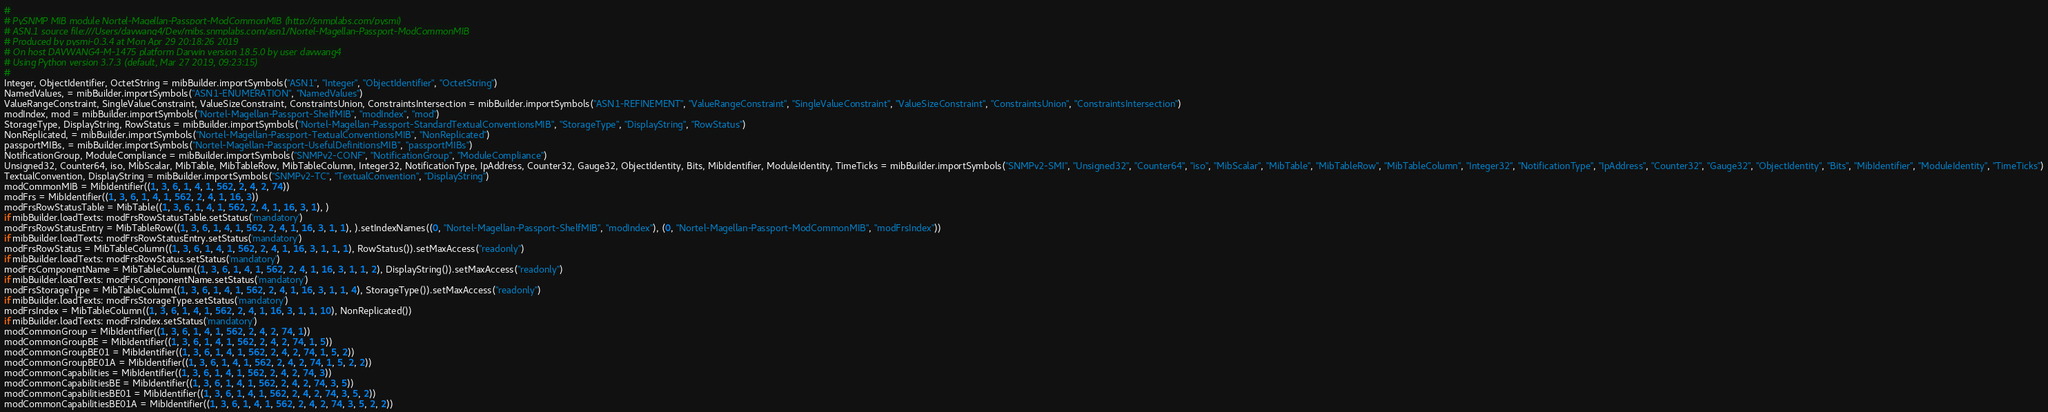<code> <loc_0><loc_0><loc_500><loc_500><_Python_>#
# PySNMP MIB module Nortel-Magellan-Passport-ModCommonMIB (http://snmplabs.com/pysmi)
# ASN.1 source file:///Users/davwang4/Dev/mibs.snmplabs.com/asn1/Nortel-Magellan-Passport-ModCommonMIB
# Produced by pysmi-0.3.4 at Mon Apr 29 20:18:26 2019
# On host DAVWANG4-M-1475 platform Darwin version 18.5.0 by user davwang4
# Using Python version 3.7.3 (default, Mar 27 2019, 09:23:15) 
#
Integer, ObjectIdentifier, OctetString = mibBuilder.importSymbols("ASN1", "Integer", "ObjectIdentifier", "OctetString")
NamedValues, = mibBuilder.importSymbols("ASN1-ENUMERATION", "NamedValues")
ValueRangeConstraint, SingleValueConstraint, ValueSizeConstraint, ConstraintsUnion, ConstraintsIntersection = mibBuilder.importSymbols("ASN1-REFINEMENT", "ValueRangeConstraint", "SingleValueConstraint", "ValueSizeConstraint", "ConstraintsUnion", "ConstraintsIntersection")
modIndex, mod = mibBuilder.importSymbols("Nortel-Magellan-Passport-ShelfMIB", "modIndex", "mod")
StorageType, DisplayString, RowStatus = mibBuilder.importSymbols("Nortel-Magellan-Passport-StandardTextualConventionsMIB", "StorageType", "DisplayString", "RowStatus")
NonReplicated, = mibBuilder.importSymbols("Nortel-Magellan-Passport-TextualConventionsMIB", "NonReplicated")
passportMIBs, = mibBuilder.importSymbols("Nortel-Magellan-Passport-UsefulDefinitionsMIB", "passportMIBs")
NotificationGroup, ModuleCompliance = mibBuilder.importSymbols("SNMPv2-CONF", "NotificationGroup", "ModuleCompliance")
Unsigned32, Counter64, iso, MibScalar, MibTable, MibTableRow, MibTableColumn, Integer32, NotificationType, IpAddress, Counter32, Gauge32, ObjectIdentity, Bits, MibIdentifier, ModuleIdentity, TimeTicks = mibBuilder.importSymbols("SNMPv2-SMI", "Unsigned32", "Counter64", "iso", "MibScalar", "MibTable", "MibTableRow", "MibTableColumn", "Integer32", "NotificationType", "IpAddress", "Counter32", "Gauge32", "ObjectIdentity", "Bits", "MibIdentifier", "ModuleIdentity", "TimeTicks")
TextualConvention, DisplayString = mibBuilder.importSymbols("SNMPv2-TC", "TextualConvention", "DisplayString")
modCommonMIB = MibIdentifier((1, 3, 6, 1, 4, 1, 562, 2, 4, 2, 74))
modFrs = MibIdentifier((1, 3, 6, 1, 4, 1, 562, 2, 4, 1, 16, 3))
modFrsRowStatusTable = MibTable((1, 3, 6, 1, 4, 1, 562, 2, 4, 1, 16, 3, 1), )
if mibBuilder.loadTexts: modFrsRowStatusTable.setStatus('mandatory')
modFrsRowStatusEntry = MibTableRow((1, 3, 6, 1, 4, 1, 562, 2, 4, 1, 16, 3, 1, 1), ).setIndexNames((0, "Nortel-Magellan-Passport-ShelfMIB", "modIndex"), (0, "Nortel-Magellan-Passport-ModCommonMIB", "modFrsIndex"))
if mibBuilder.loadTexts: modFrsRowStatusEntry.setStatus('mandatory')
modFrsRowStatus = MibTableColumn((1, 3, 6, 1, 4, 1, 562, 2, 4, 1, 16, 3, 1, 1, 1), RowStatus()).setMaxAccess("readonly")
if mibBuilder.loadTexts: modFrsRowStatus.setStatus('mandatory')
modFrsComponentName = MibTableColumn((1, 3, 6, 1, 4, 1, 562, 2, 4, 1, 16, 3, 1, 1, 2), DisplayString()).setMaxAccess("readonly")
if mibBuilder.loadTexts: modFrsComponentName.setStatus('mandatory')
modFrsStorageType = MibTableColumn((1, 3, 6, 1, 4, 1, 562, 2, 4, 1, 16, 3, 1, 1, 4), StorageType()).setMaxAccess("readonly")
if mibBuilder.loadTexts: modFrsStorageType.setStatus('mandatory')
modFrsIndex = MibTableColumn((1, 3, 6, 1, 4, 1, 562, 2, 4, 1, 16, 3, 1, 1, 10), NonReplicated())
if mibBuilder.loadTexts: modFrsIndex.setStatus('mandatory')
modCommonGroup = MibIdentifier((1, 3, 6, 1, 4, 1, 562, 2, 4, 2, 74, 1))
modCommonGroupBE = MibIdentifier((1, 3, 6, 1, 4, 1, 562, 2, 4, 2, 74, 1, 5))
modCommonGroupBE01 = MibIdentifier((1, 3, 6, 1, 4, 1, 562, 2, 4, 2, 74, 1, 5, 2))
modCommonGroupBE01A = MibIdentifier((1, 3, 6, 1, 4, 1, 562, 2, 4, 2, 74, 1, 5, 2, 2))
modCommonCapabilities = MibIdentifier((1, 3, 6, 1, 4, 1, 562, 2, 4, 2, 74, 3))
modCommonCapabilitiesBE = MibIdentifier((1, 3, 6, 1, 4, 1, 562, 2, 4, 2, 74, 3, 5))
modCommonCapabilitiesBE01 = MibIdentifier((1, 3, 6, 1, 4, 1, 562, 2, 4, 2, 74, 3, 5, 2))
modCommonCapabilitiesBE01A = MibIdentifier((1, 3, 6, 1, 4, 1, 562, 2, 4, 2, 74, 3, 5, 2, 2))</code> 